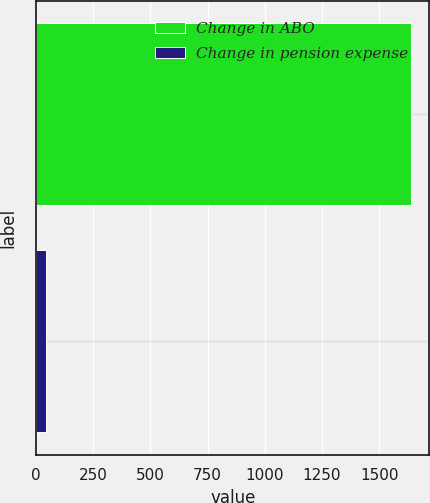Convert chart to OTSL. <chart><loc_0><loc_0><loc_500><loc_500><bar_chart><fcel>Change in ABO<fcel>Change in pension expense<nl><fcel>1638<fcel>44<nl></chart> 